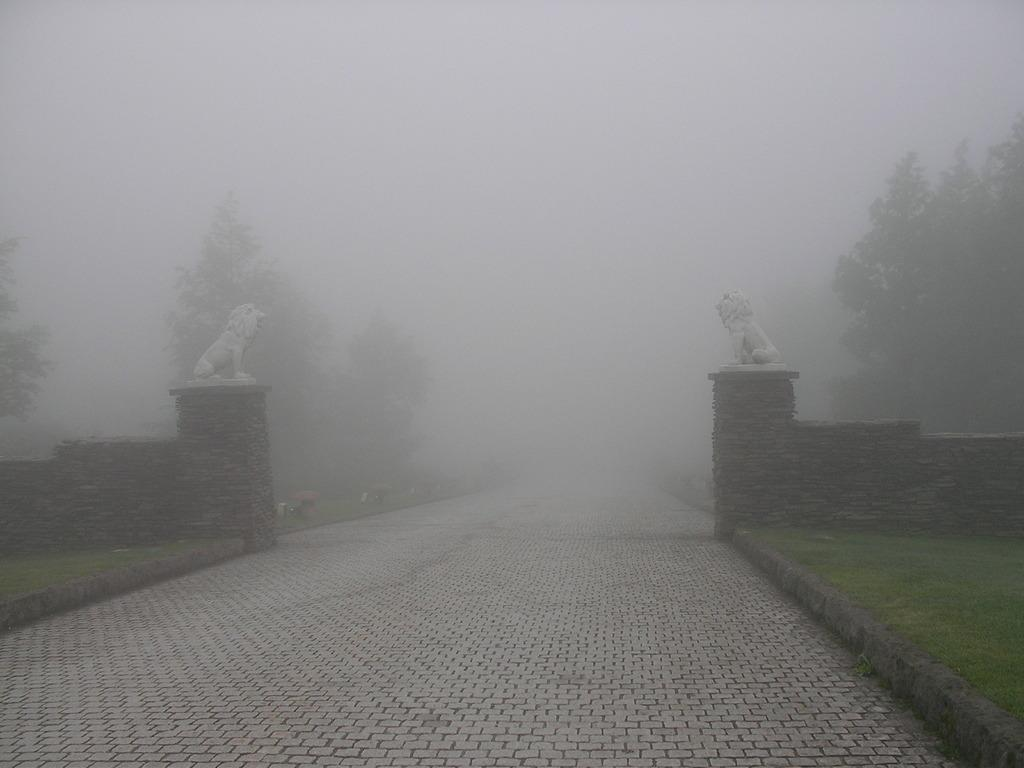What is the main feature of the image? There is a road in the image. Are there any other objects or structures near the road? Yes, there are statues on the wall near the road. What can be seen in the background of the image? There are many trees and fog visible in the background of the image. Can you hear the rat laughing in the image? There is no rat or laughter present in the image. 